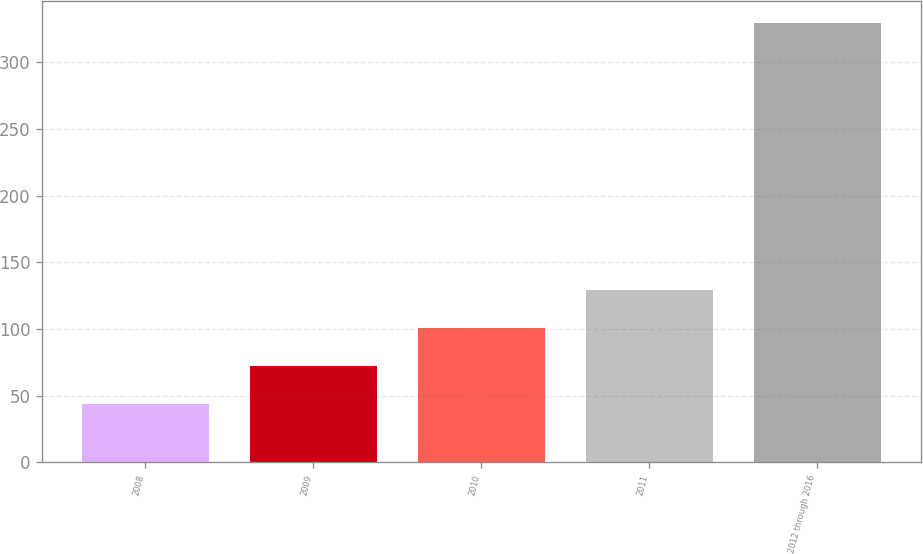<chart> <loc_0><loc_0><loc_500><loc_500><bar_chart><fcel>2008<fcel>2009<fcel>2010<fcel>2011<fcel>2012 through 2016<nl><fcel>44<fcel>72.5<fcel>101<fcel>129.5<fcel>329<nl></chart> 